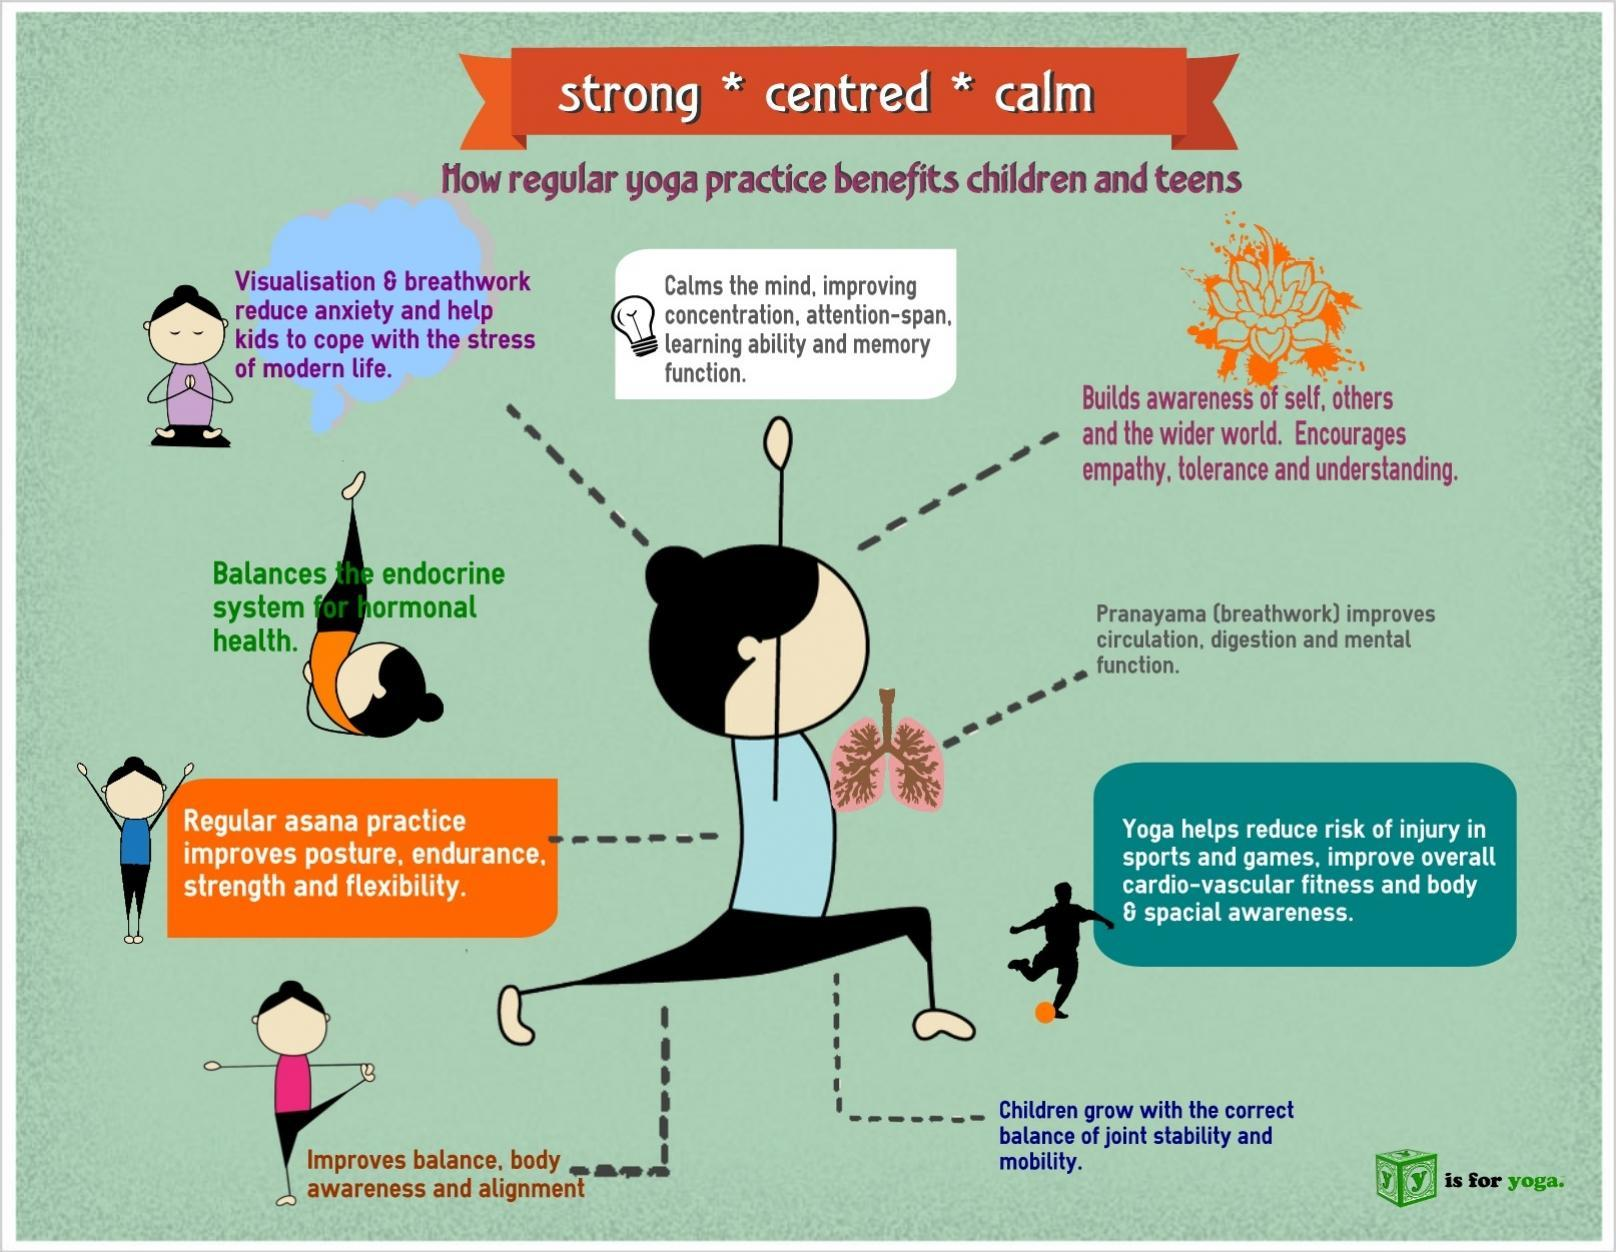How many benefits can be received by the children through yoga?
Answer the question with a short phrase. 9 Which breathing exercise helps in reducing anxiety among kids? Pranayama 